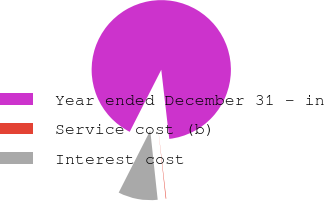Convert chart. <chart><loc_0><loc_0><loc_500><loc_500><pie_chart><fcel>Year ended December 31 - in<fcel>Service cost (b)<fcel>Interest cost<nl><fcel>90.68%<fcel>0.13%<fcel>9.19%<nl></chart> 